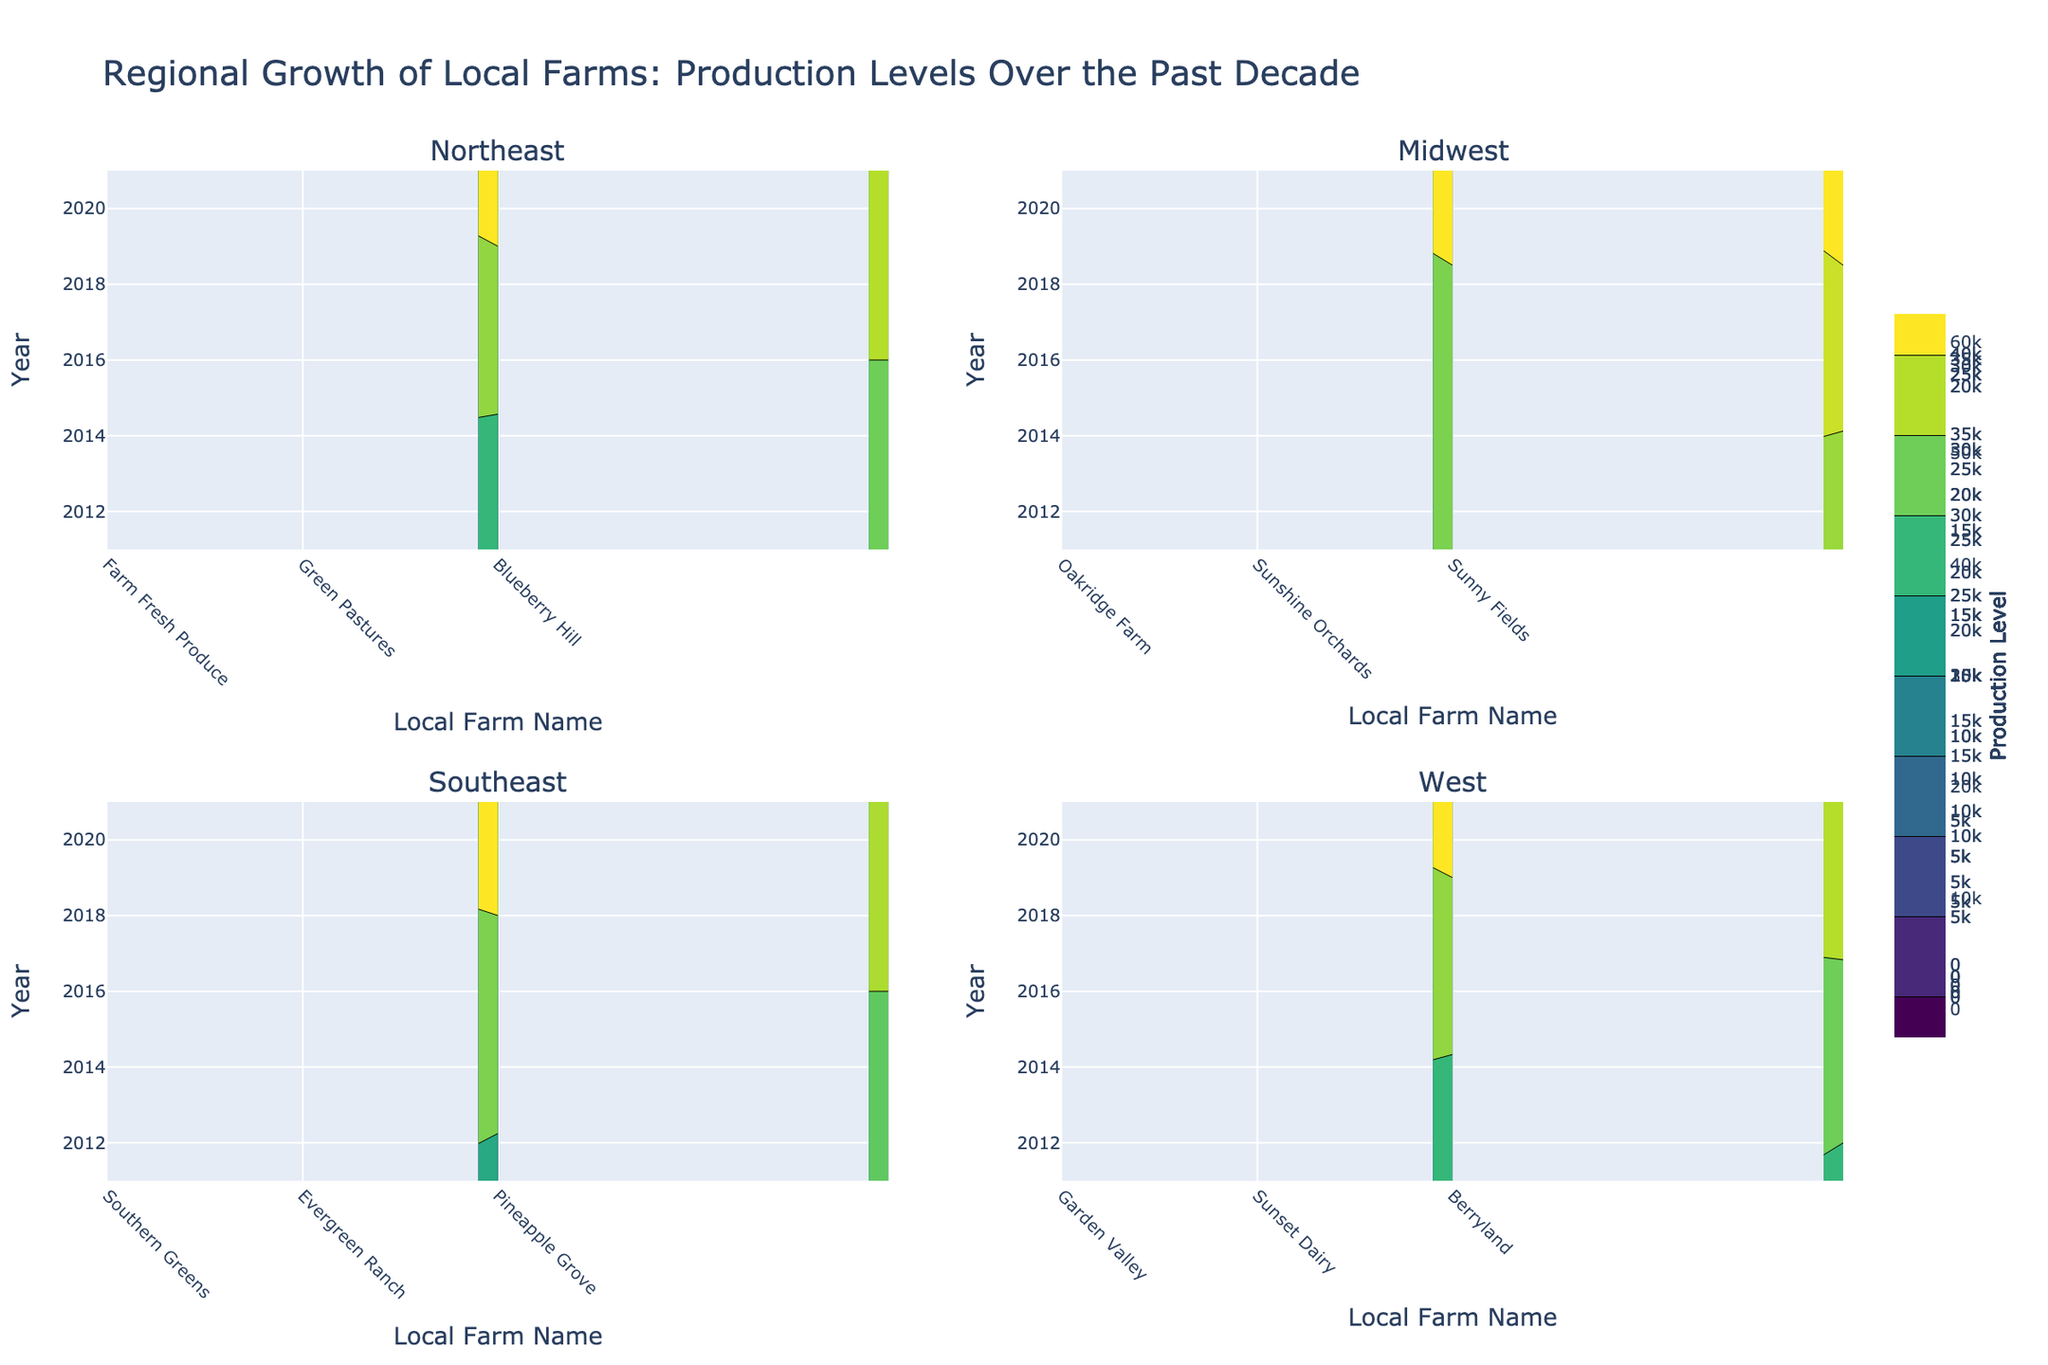What is the title of the plot? The title of the plot is displayed at the top of the figure and it reads "Regional Growth of Local Farms: Production Levels Over the Past Decade"
Answer: Regional Growth of Local Farms: Production Levels Over the Past Decade Which region has the highest production level for vegetables in 2021? To find this, look at each of the four subplots. Identify the 'Vegetables' contour in 2021 and compare the production levels. The West region shows the highest production level for vegetables at 38,000.
Answer: West How many regions are included in the plot? There are four subplot titles, each representing a different region. Thus, there are four regions included: Northeast, Midwest, Southeast, and West.
Answer: Four What is the overall trend for dairy production in the Northeast region from 2011 to 2021? By observing the contour representing dairy production in the Northeast subplot from 2011 to 2021, you can see that the production levels generally increase over time, from 15,000 in 2011 to 27,000 in 2021.
Answer: Increasing Between the Midwest and Southeast regions, which one shows a higher increase in fruit production from 2011 to 2021? Compare the fruit production levels in 2011 and 2021 for both regions. For the Midwest, it increases from 15,000 to 21,000. For the Southeast, it increases from 25,000 to 35,000. The Southeast shows a higher increase.
Answer: Southeast Which region has the most diverse production levels among different farms for grains in 2021? Since grains are only produced in the Midwest for this dataset, we only need to look at the Midwest subplot. The production level for Sunny Fields (the only farm producing grains) in 2021 is 62,000. This question was actually aiming for diversity across farms, which the Midwest doesn't show for grains. Hence, none of the regions are diverse in grain production as only one farm produces it.
Answer: None What year shows the highest production level for vegetables in the Southeast region? In the Southeast subplot, observe the contour for vegetables across the years. The production level for vegetables in 2021 is the highest at 33,000.
Answer: 2021 Are there any regions where fruit production stayed constant or decreased over the past decade? By examining the contours for fruit production in each region from 2011 to 2021, none of the regions show a constant or decreasing trend; all show some level of increase.
Answer: No What is the maximum production level for dairy in the West region? In the West subplot, look for the maximum value in the contour representing dairy production, which is found to be 27,000 in 2021.
Answer: 27,000 